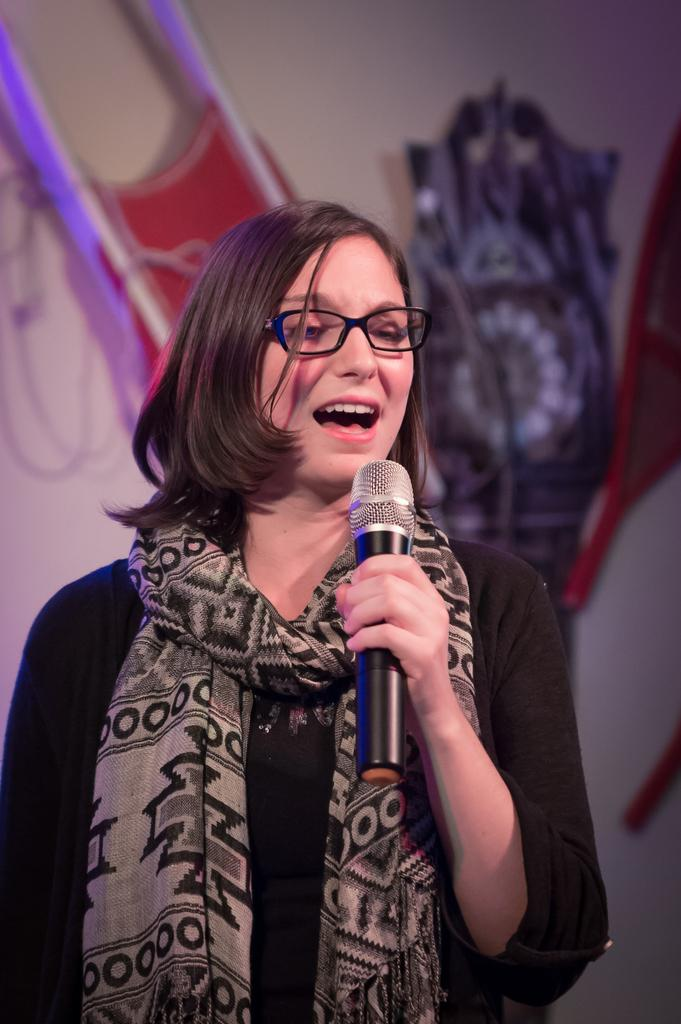Who is the main subject in the image? There is a woman in the image. What is the woman wearing? The woman is wearing a black dress and a scarf. What is the woman holding in the image? The woman is holding a microphone. What is the woman doing in the image? The woman is singing a song. What can be seen in the background of the image? There is a wall in the background of the image, and there are items on the wall. How many ducks are visible in the image? There are no ducks present in the image. What type of pets does the woman have in the image? There is no information about pets in the image. 